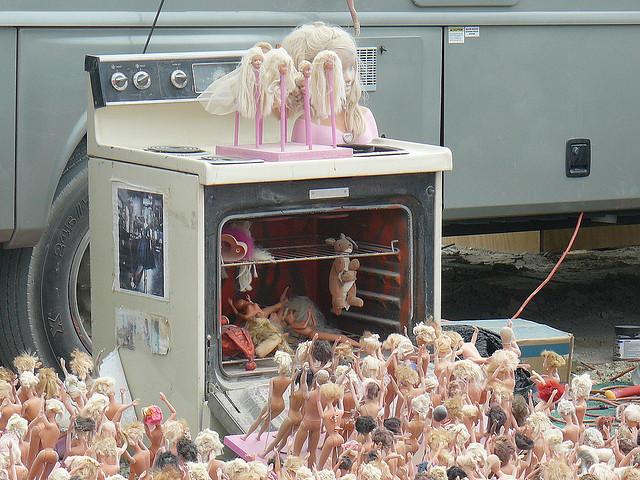Are the people here real?
Be succinct. No. What kind of dolls?
Answer briefly. Barbie. Are the dolls wearing clothes?
Be succinct. No. 